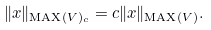<formula> <loc_0><loc_0><loc_500><loc_500>\| x \| _ { \text {MAX} ( V ) _ { c } } = c \| x \| _ { \text {MAX} ( V ) } .</formula> 